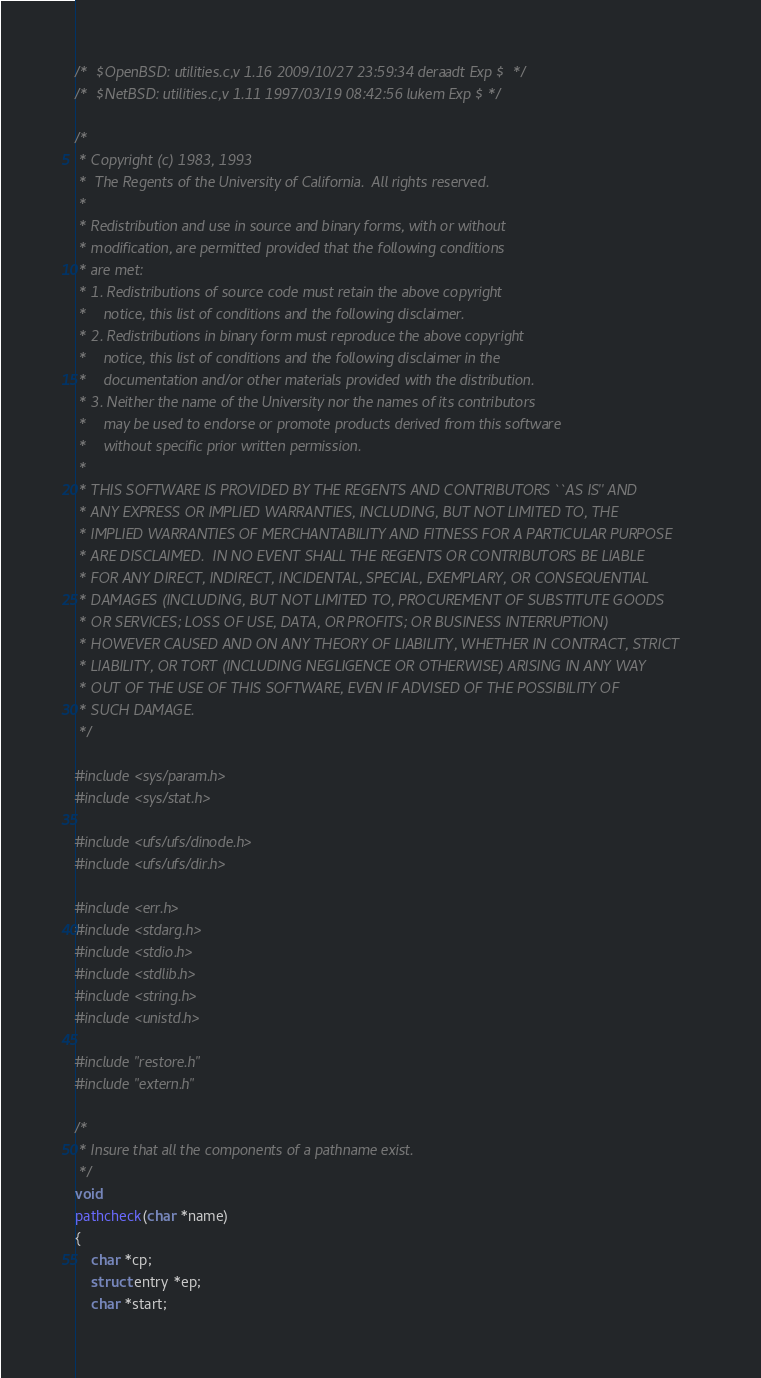Convert code to text. <code><loc_0><loc_0><loc_500><loc_500><_C_>/*	$OpenBSD: utilities.c,v 1.16 2009/10/27 23:59:34 deraadt Exp $	*/
/*	$NetBSD: utilities.c,v 1.11 1997/03/19 08:42:56 lukem Exp $	*/

/*
 * Copyright (c) 1983, 1993
 *	The Regents of the University of California.  All rights reserved.
 *
 * Redistribution and use in source and binary forms, with or without
 * modification, are permitted provided that the following conditions
 * are met:
 * 1. Redistributions of source code must retain the above copyright
 *    notice, this list of conditions and the following disclaimer.
 * 2. Redistributions in binary form must reproduce the above copyright
 *    notice, this list of conditions and the following disclaimer in the
 *    documentation and/or other materials provided with the distribution.
 * 3. Neither the name of the University nor the names of its contributors
 *    may be used to endorse or promote products derived from this software
 *    without specific prior written permission.
 *
 * THIS SOFTWARE IS PROVIDED BY THE REGENTS AND CONTRIBUTORS ``AS IS'' AND
 * ANY EXPRESS OR IMPLIED WARRANTIES, INCLUDING, BUT NOT LIMITED TO, THE
 * IMPLIED WARRANTIES OF MERCHANTABILITY AND FITNESS FOR A PARTICULAR PURPOSE
 * ARE DISCLAIMED.  IN NO EVENT SHALL THE REGENTS OR CONTRIBUTORS BE LIABLE
 * FOR ANY DIRECT, INDIRECT, INCIDENTAL, SPECIAL, EXEMPLARY, OR CONSEQUENTIAL
 * DAMAGES (INCLUDING, BUT NOT LIMITED TO, PROCUREMENT OF SUBSTITUTE GOODS
 * OR SERVICES; LOSS OF USE, DATA, OR PROFITS; OR BUSINESS INTERRUPTION)
 * HOWEVER CAUSED AND ON ANY THEORY OF LIABILITY, WHETHER IN CONTRACT, STRICT
 * LIABILITY, OR TORT (INCLUDING NEGLIGENCE OR OTHERWISE) ARISING IN ANY WAY
 * OUT OF THE USE OF THIS SOFTWARE, EVEN IF ADVISED OF THE POSSIBILITY OF
 * SUCH DAMAGE.
 */

#include <sys/param.h>
#include <sys/stat.h>

#include <ufs/ufs/dinode.h>
#include <ufs/ufs/dir.h>

#include <err.h>
#include <stdarg.h>
#include <stdio.h>
#include <stdlib.h>
#include <string.h>
#include <unistd.h>

#include "restore.h"
#include "extern.h"

/*
 * Insure that all the components of a pathname exist.
 */
void
pathcheck(char *name)
{
	char *cp;
	struct entry *ep;
	char *start;
</code> 